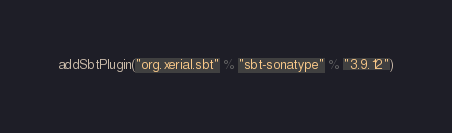<code> <loc_0><loc_0><loc_500><loc_500><_Scala_>addSbtPlugin("org.xerial.sbt" % "sbt-sonatype" % "3.9.12")
</code> 